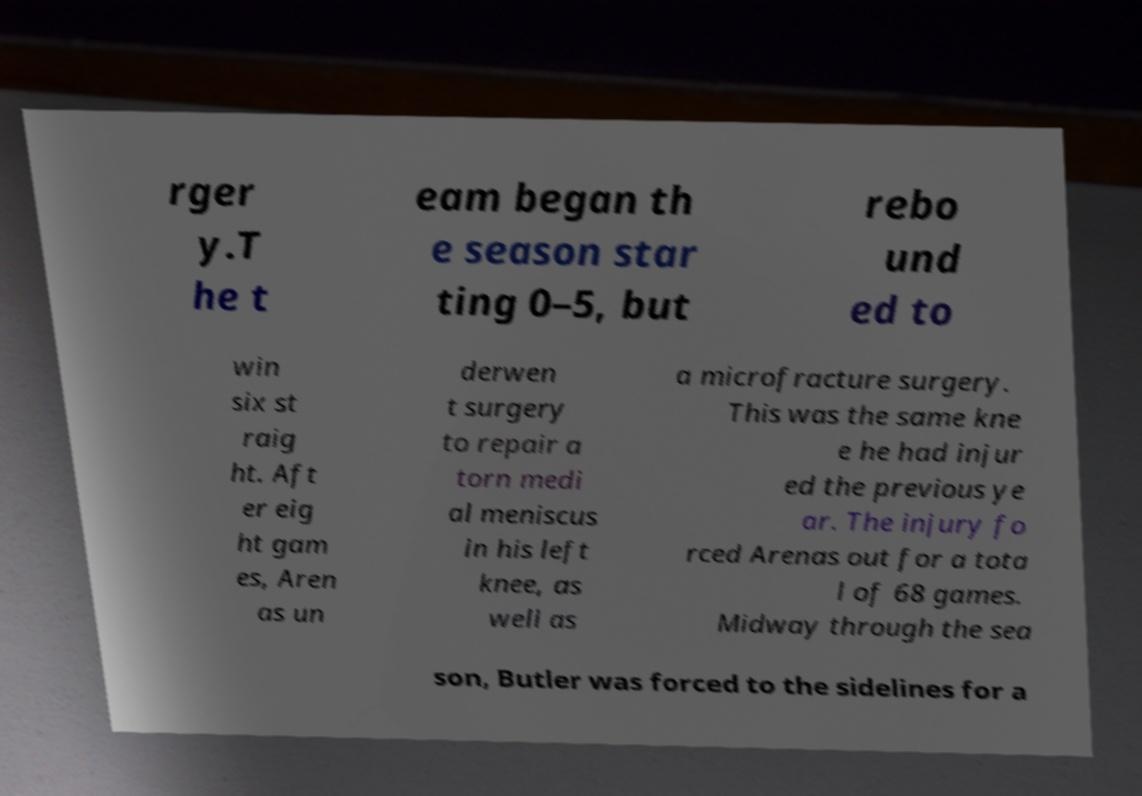What messages or text are displayed in this image? I need them in a readable, typed format. rger y.T he t eam began th e season star ting 0–5, but rebo und ed to win six st raig ht. Aft er eig ht gam es, Aren as un derwen t surgery to repair a torn medi al meniscus in his left knee, as well as a microfracture surgery. This was the same kne e he had injur ed the previous ye ar. The injury fo rced Arenas out for a tota l of 68 games. Midway through the sea son, Butler was forced to the sidelines for a 